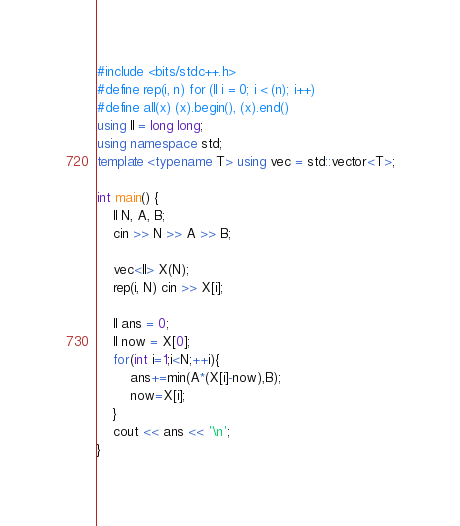<code> <loc_0><loc_0><loc_500><loc_500><_C++_>#include <bits/stdc++.h>
#define rep(i, n) for (ll i = 0; i < (n); i++)
#define all(x) (x).begin(), (x).end()
using ll = long long;
using namespace std;
template <typename T> using vec = std::vector<T>;

int main() {
    ll N, A, B;
    cin >> N >> A >> B;
    
    vec<ll> X(N);
    rep(i, N) cin >> X[i];

    ll ans = 0;
    ll now = X[0];
    for(int i=1;i<N;++i){
        ans+=min(A*(X[i]-now),B);
        now=X[i];
    }
    cout << ans << '\n';
}
</code> 